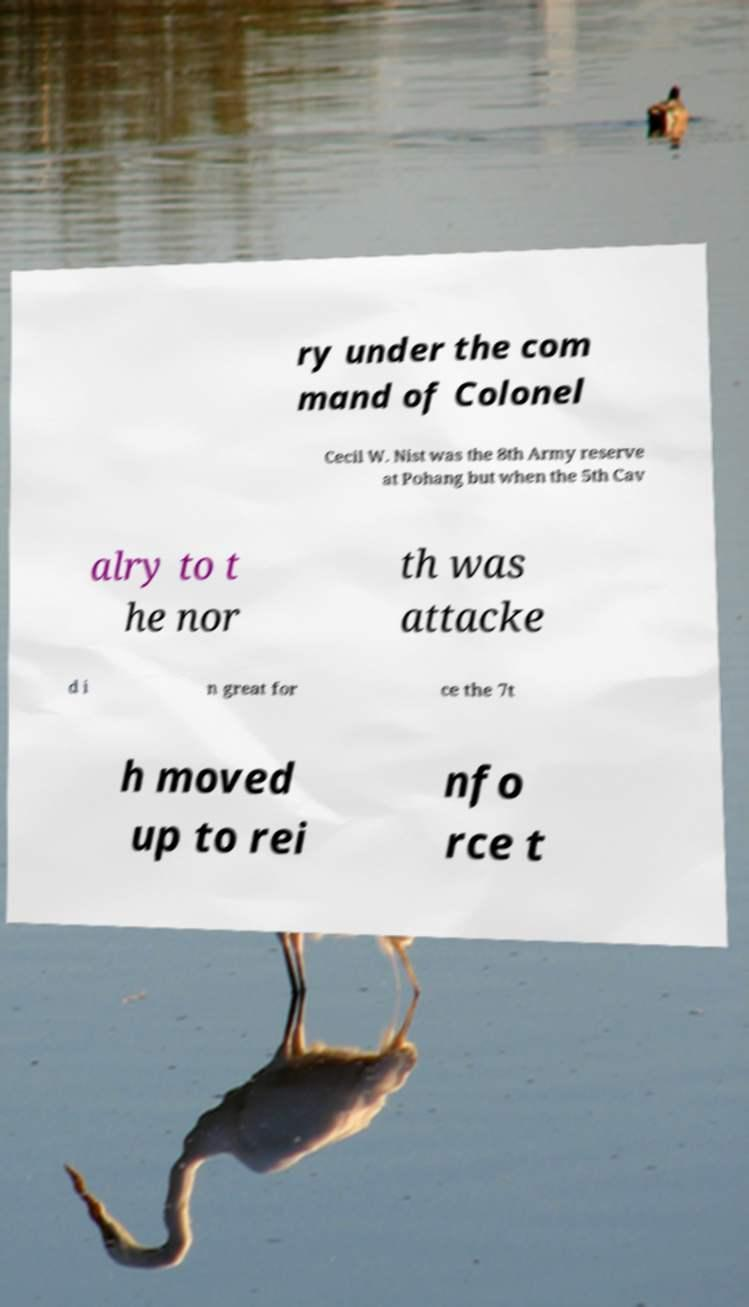I need the written content from this picture converted into text. Can you do that? ry under the com mand of Colonel Cecil W. Nist was the 8th Army reserve at Pohang but when the 5th Cav alry to t he nor th was attacke d i n great for ce the 7t h moved up to rei nfo rce t 